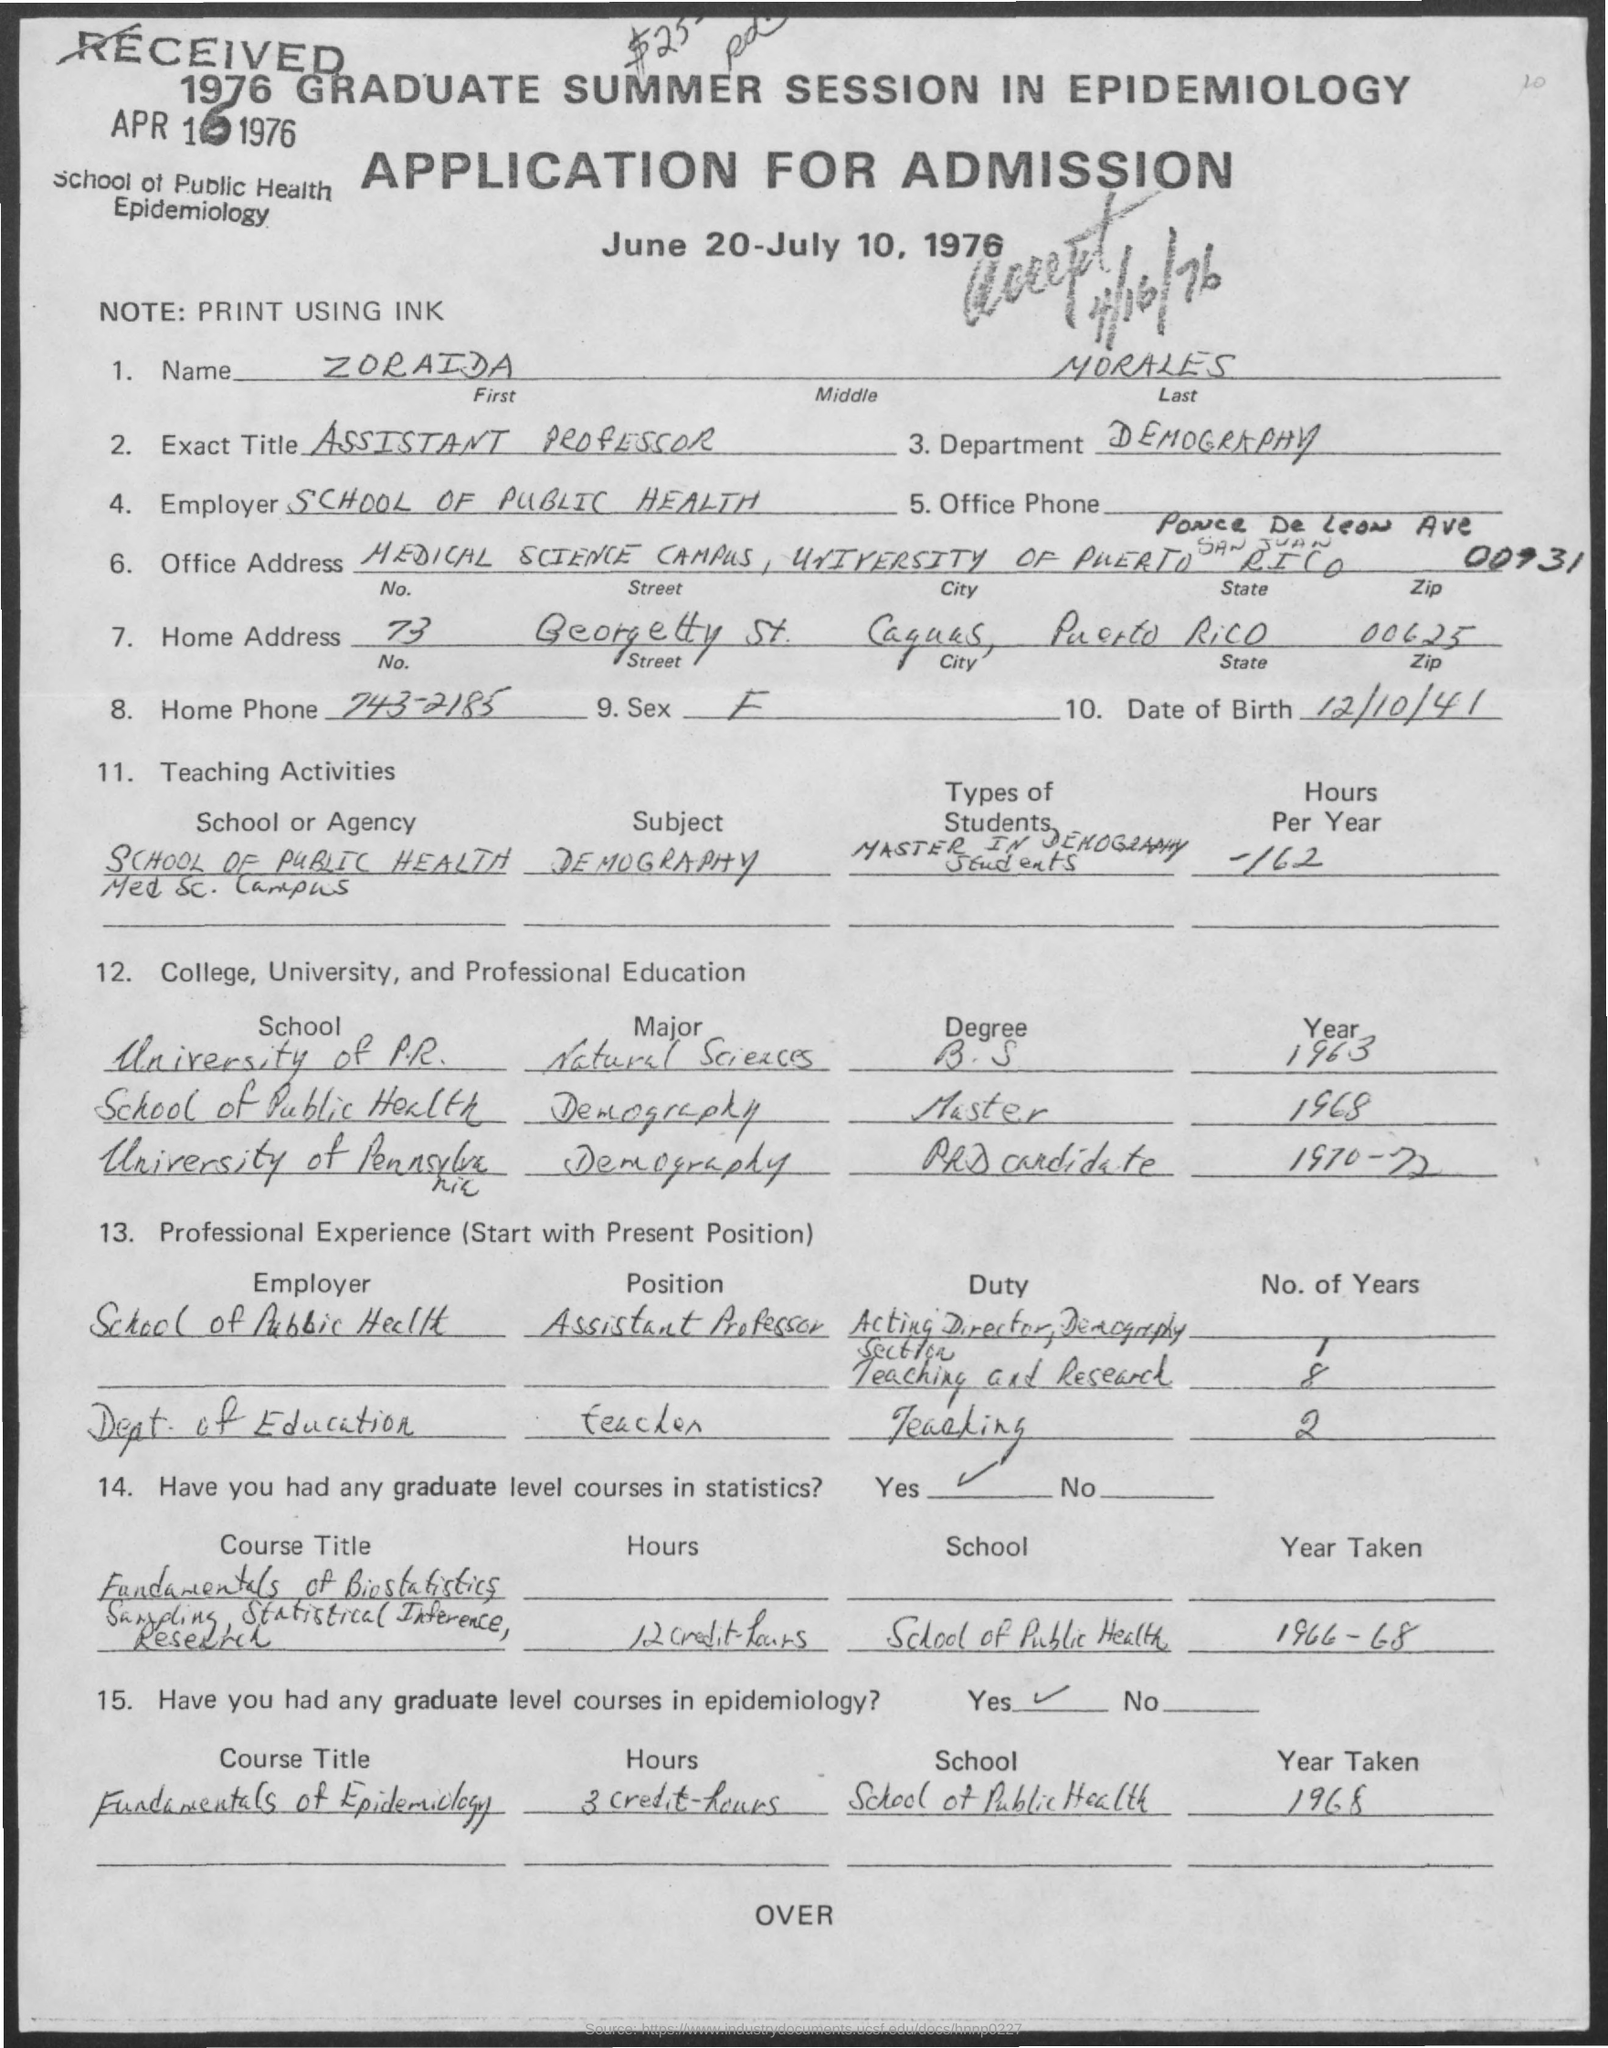What is the First name of the applicant given here?
Offer a very short reply. ZORAIDA. What is the Exact Title of Zoraida Morales?
Give a very brief answer. ASSISTANT PROFESSOR. What is the Home Phone no of Zoraida Morales?
Your answer should be compact. 743-2185. What is the date of birth of Zoraida Morales?
Keep it short and to the point. 12/10/41. Who is the current employer of Zoraida Morales?
Keep it short and to the point. SCHOOL OF PUBLIC HEALTH. What is the accepted date of this application?
Your answer should be very brief. 4/16/76. What is the zipcode mentioned in the home address?
Offer a terse response. 00625. In which year, Zoraida Morales completed Masters in Demography?
Provide a succinct answer. 1968. In which university, Zoraida Morales has completed B.S. in Natural Sciences in 1963?
Your answer should be very brief. University of P.R. 